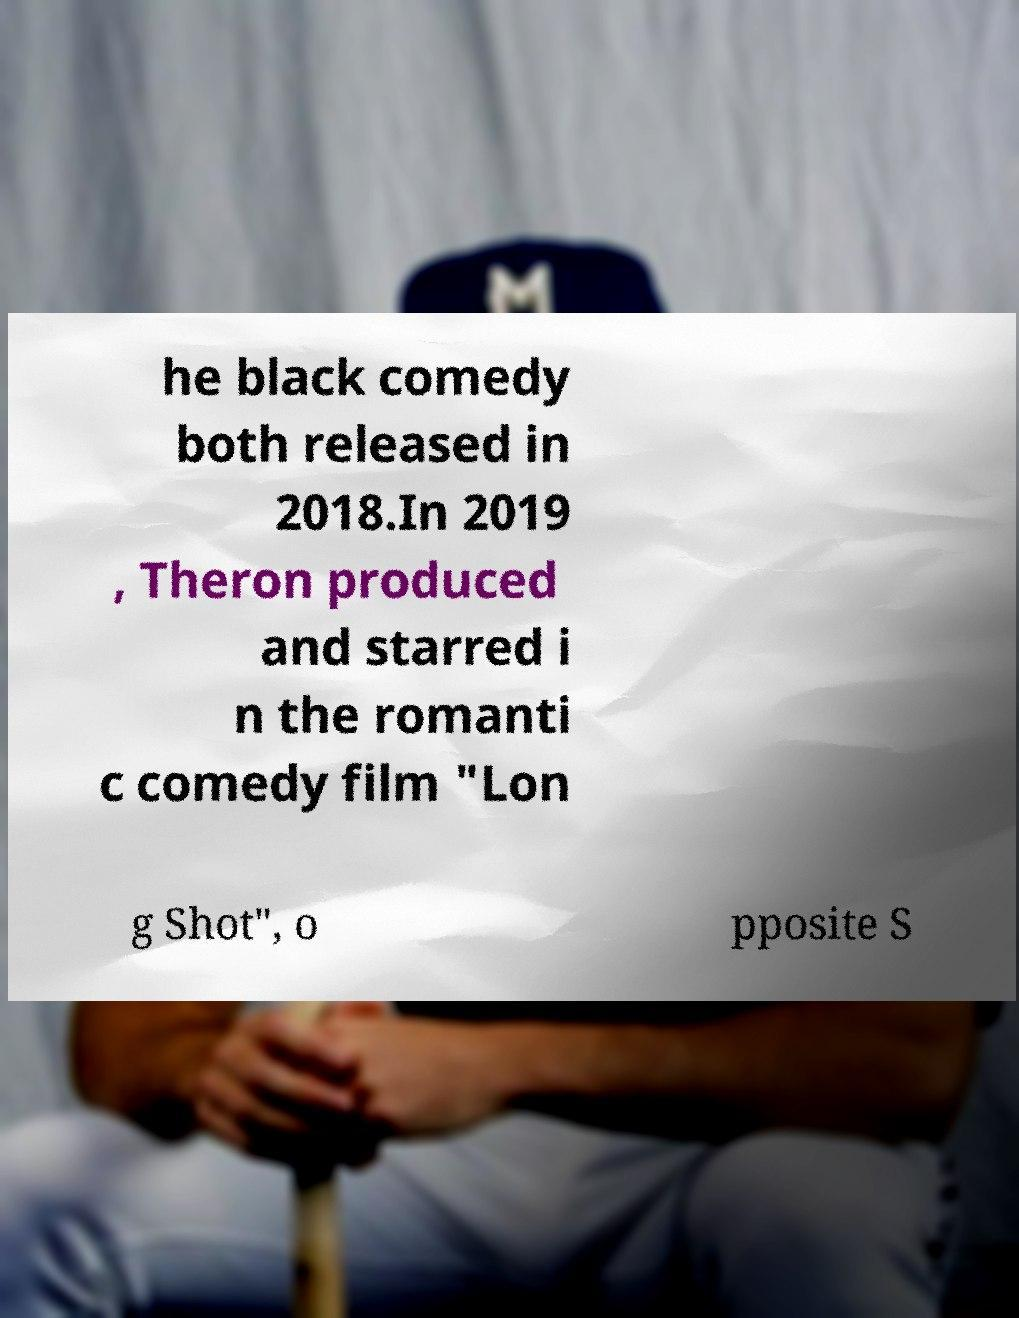I need the written content from this picture converted into text. Can you do that? he black comedy both released in 2018.In 2019 , Theron produced and starred i n the romanti c comedy film "Lon g Shot", o pposite S 